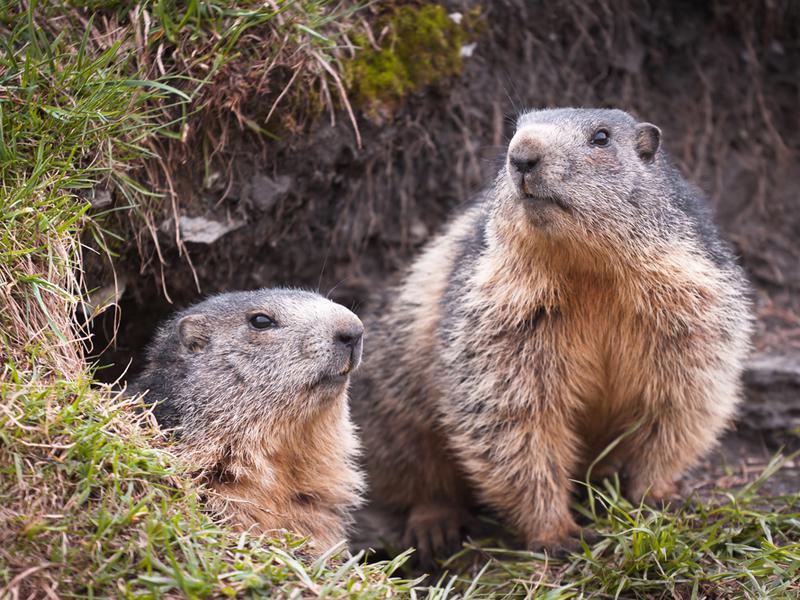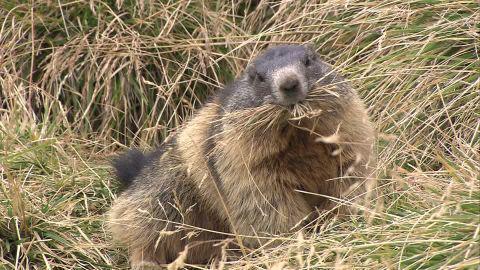The first image is the image on the left, the second image is the image on the right. Considering the images on both sides, is "There is a groundhog-like animal standing straight up with its paws in the air." valid? Answer yes or no. No. 